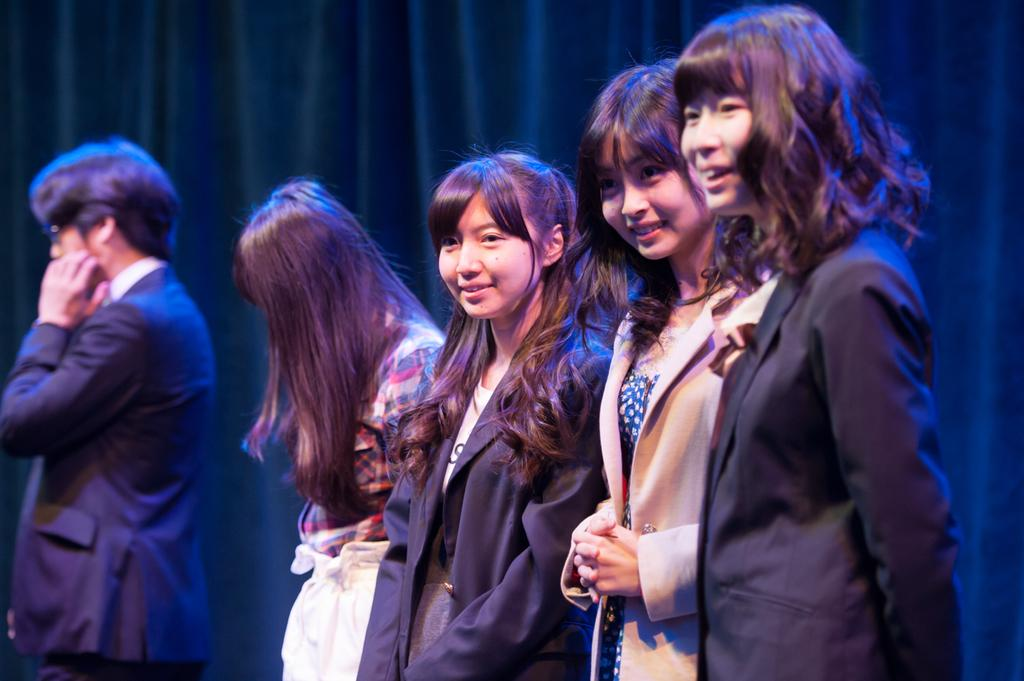How many people are in the image? There are four girls and a man in the image, making a total of five people. What are the people in the image doing? The people are standing in the image. What can be observed about the facial expressions of the people? Three of the girls are smiling in the image. What can be seen in the background of the image? There are curtains visible in the background. What type of circle is being used to promote peace in the image? There is no circle or reference to promoting peace in the image. 